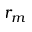Convert formula to latex. <formula><loc_0><loc_0><loc_500><loc_500>r _ { m }</formula> 